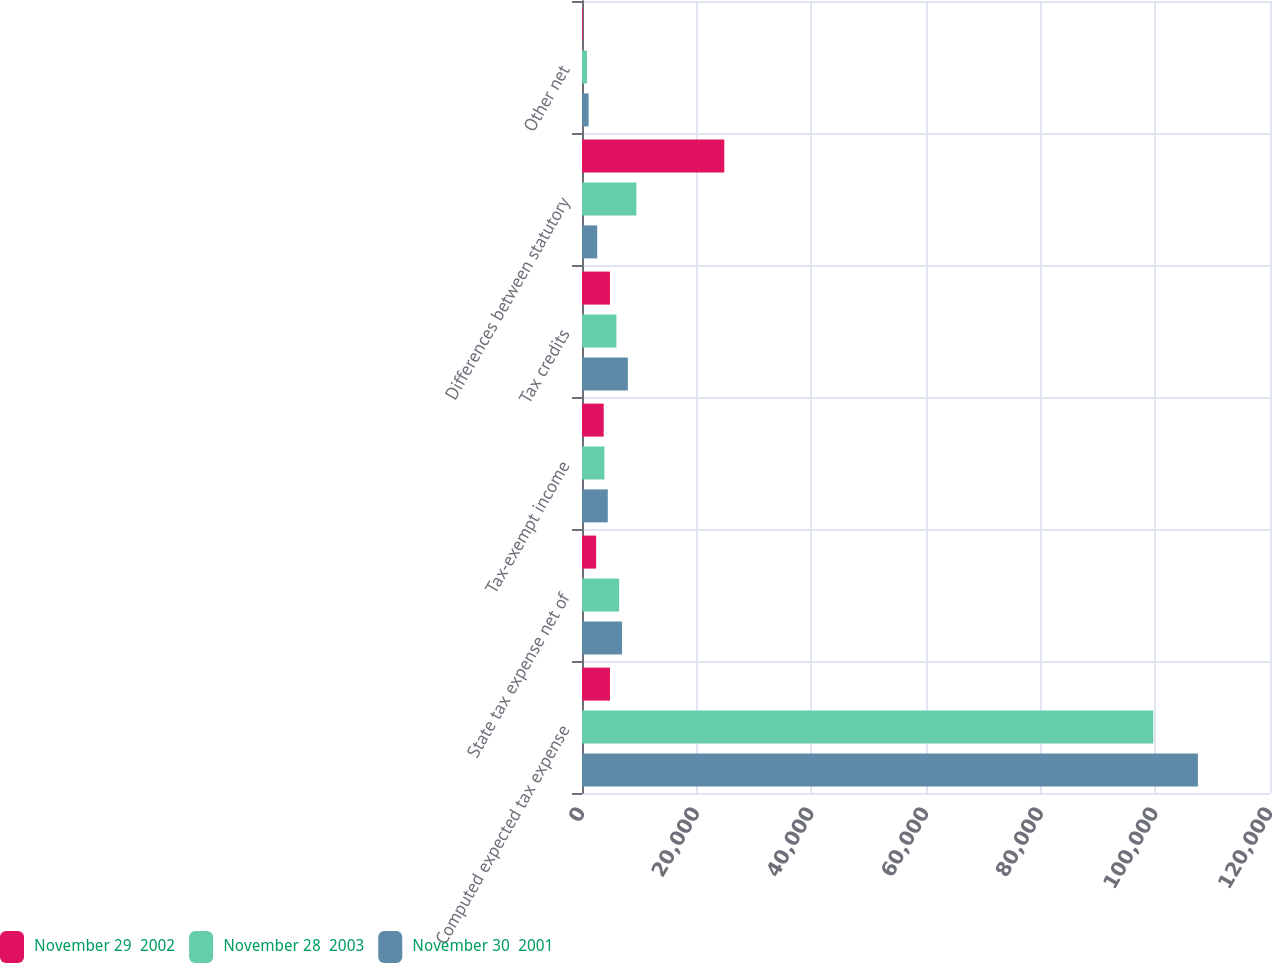Convert chart to OTSL. <chart><loc_0><loc_0><loc_500><loc_500><stacked_bar_chart><ecel><fcel>Computed expected tax expense<fcel>State tax expense net of<fcel>Tax-exempt income<fcel>Tax credits<fcel>Differences between statutory<fcel>Other net<nl><fcel>November 29  2002<fcel>4878<fcel>2473<fcel>3786<fcel>4878<fcel>24816<fcel>127<nl><fcel>November 28  2003<fcel>99641<fcel>6477<fcel>3915<fcel>6000<fcel>9487<fcel>863<nl><fcel>November 30  2001<fcel>107426<fcel>6983<fcel>4496<fcel>8000<fcel>2653<fcel>1151<nl></chart> 